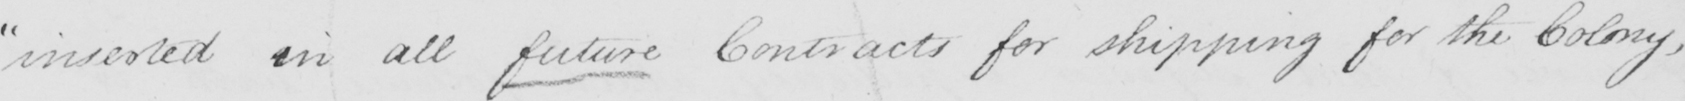What does this handwritten line say? " inserted in all future Contracts for shipping for the Colony , 